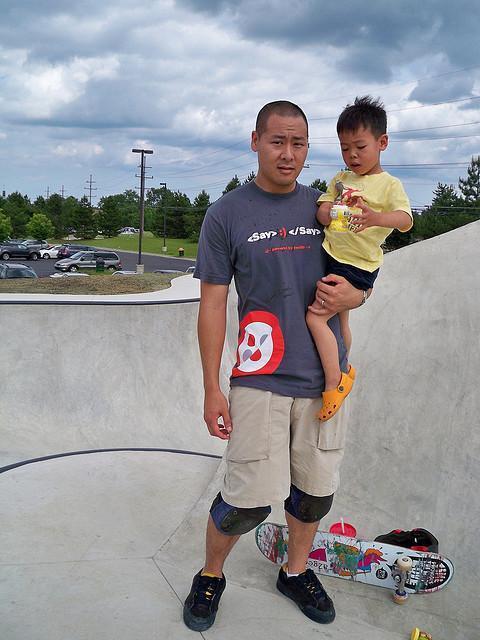How many people are in the photo?
Give a very brief answer. 2. 